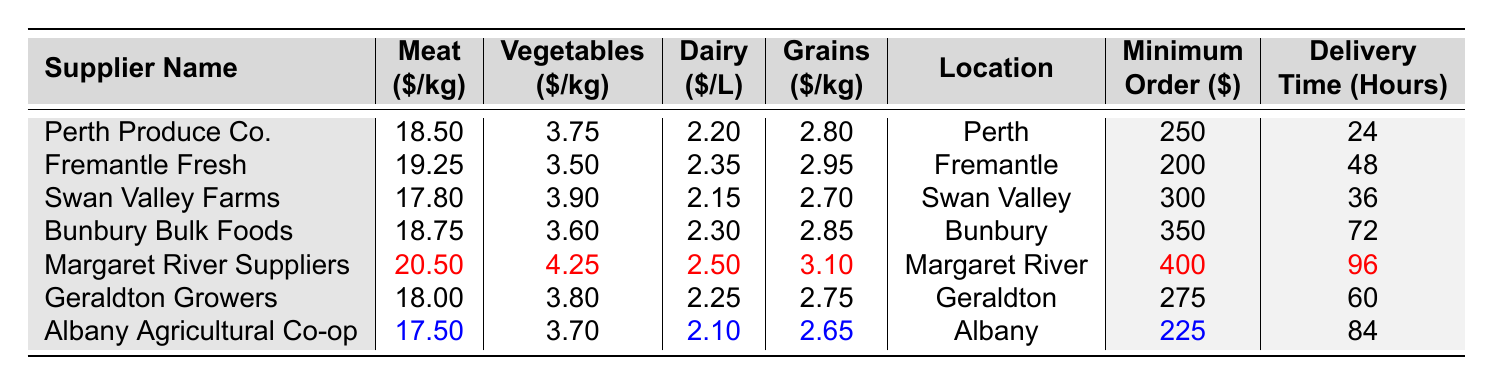What is the cost of meat from Swan Valley Farms? Look at the "Meat ($/kg)" column for "Swan Valley Farms," which shows 17.80.
Answer: 17.80 Which supplier has the lowest cost for vegetables? In the "Vegetables ($/kg)" column, compare all values; "Fremantle Fresh" at 3.50 is the lowest.
Answer: Fremantle Fresh What is the delivery time for Margaret River Suppliers? Check the "Delivery Time (Hours)" column for "Margaret River Suppliers," which states 96 hours.
Answer: 96 Calculate the average price of dairy across all suppliers. Add all dairy prices: (2.20 + 2.35 + 2.15 + 2.30 + 2.50 + 2.25 + 2.10) = 15.85, and divide by 7 suppliers, resulting in an average of 15.85 / 7 = 2.26.
Answer: 2.26 Is the minimum order at Geraldton Growers less than $300? The minimum order at Geraldton Growers is 275, which is less than 300.
Answer: Yes What is the difference in meat costs between Albany Agricultural Co-op and Bunbury Bulk Foods? Albany Agricultural Co-op has a meat cost of 17.50, and Bunbury Bulk Foods has 18.75; calculating the difference: 18.75 - 17.50 = 1.25.
Answer: 1.25 Which supplier has the shortest delivery time? Compare the "Delivery Time (Hours)" for all suppliers; "Perth Produce Co." has the shortest delivery time of 24 hours.
Answer: Perth Produce Co What is the total minimum order cost for all suppliers? Add all minimum order costs: (250 + 200 + 300 + 350 + 400 + 275 + 225) = 2000.
Answer: 2000 Is the vegetable cost from Geraldton Growers higher than that from Albany Agricultural Co-op? Geraldton Growers has a vegetable cost of 3.80, while Albany Agricultural Co-op has 3.70; since 3.80 > 3.70, it is true.
Answer: Yes Which supplier offers dairy at the highest price? The "Dairy ($/L)" column shows "Margaret River Suppliers" at 2.50, the highest among all suppliers.
Answer: Margaret River Suppliers 